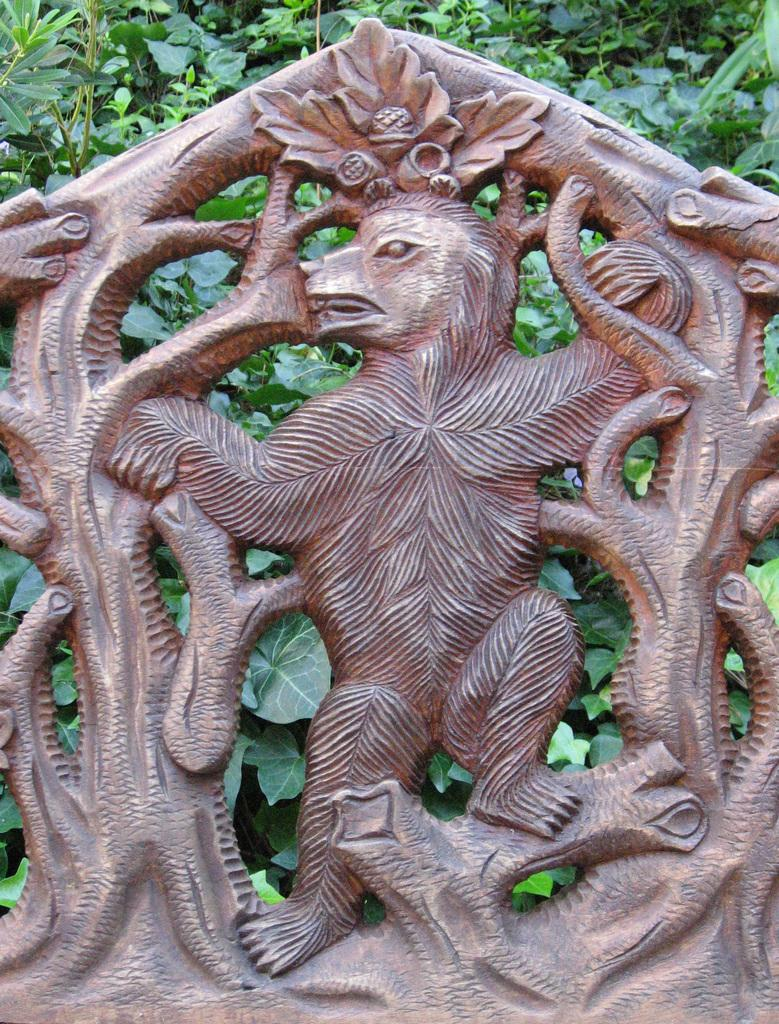What is the main subject of the image? There is a sculpture in the image. What can be seen in the background of the image? There are plants in the background of the image. Can you tell me how many monkeys are exchanging bananas in the image? There are no monkeys or bananas present in the image; it features a sculpture and plants in the background. 